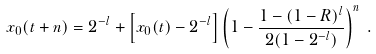<formula> <loc_0><loc_0><loc_500><loc_500>x _ { 0 } ( t + n ) = 2 ^ { - l } + \left [ x _ { 0 } ( t ) - 2 ^ { - l } \right ] \left ( 1 - \frac { 1 - ( 1 - R ) ^ { l } } { 2 ( 1 - 2 ^ { - l } ) } \right ) ^ { n } \, .</formula> 